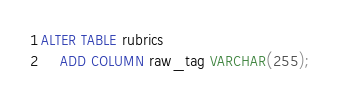<code> <loc_0><loc_0><loc_500><loc_500><_SQL_>ALTER TABLE rubrics
    ADD COLUMN raw_tag VARCHAR(255);
</code> 